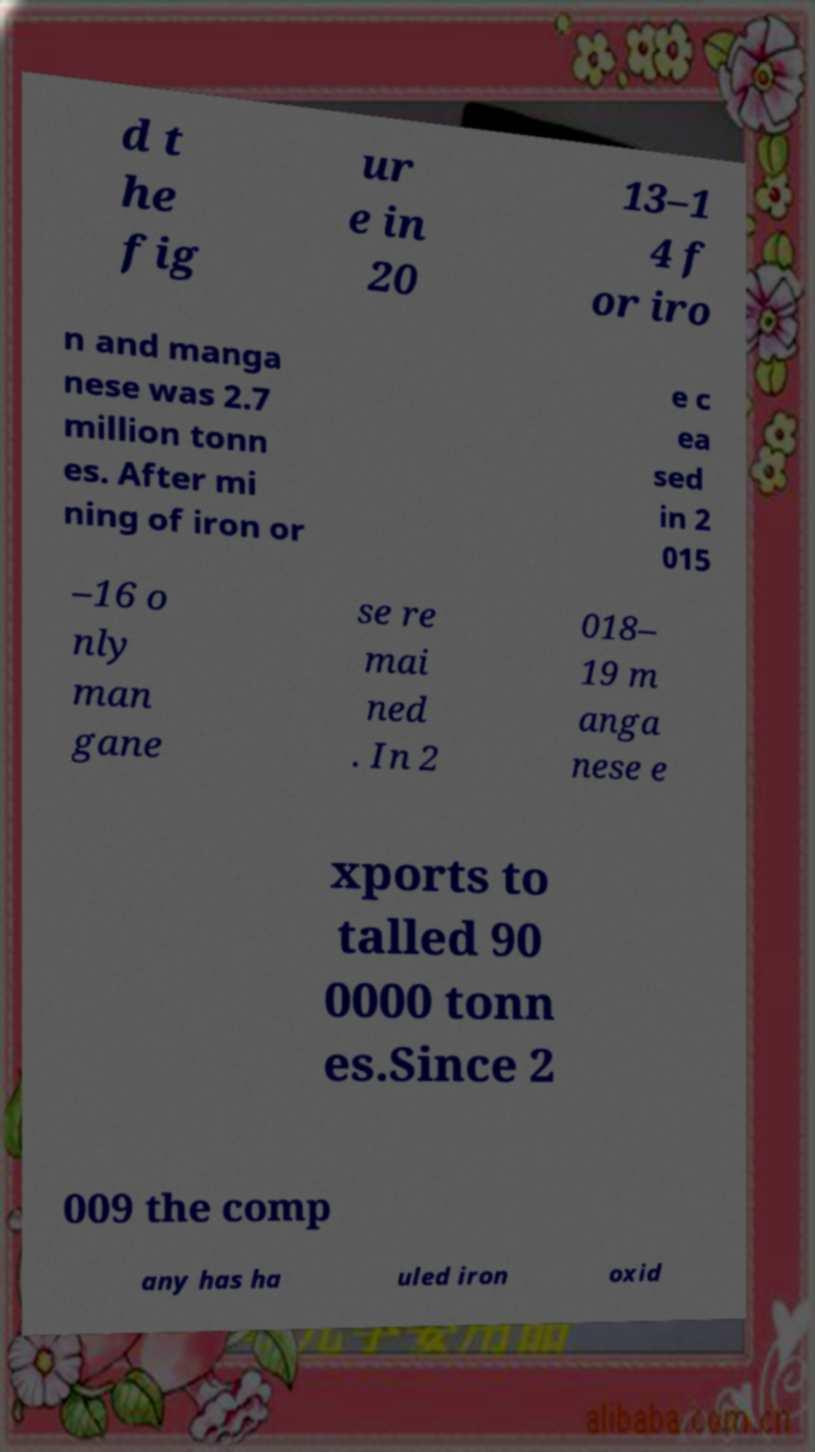For documentation purposes, I need the text within this image transcribed. Could you provide that? d t he fig ur e in 20 13–1 4 f or iro n and manga nese was 2.7 million tonn es. After mi ning of iron or e c ea sed in 2 015 –16 o nly man gane se re mai ned . In 2 018– 19 m anga nese e xports to talled 90 0000 tonn es.Since 2 009 the comp any has ha uled iron oxid 